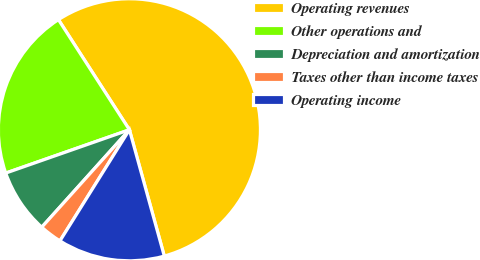<chart> <loc_0><loc_0><loc_500><loc_500><pie_chart><fcel>Operating revenues<fcel>Other operations and<fcel>Depreciation and amortization<fcel>Taxes other than income taxes<fcel>Operating income<nl><fcel>54.82%<fcel>21.25%<fcel>7.98%<fcel>2.77%<fcel>13.18%<nl></chart> 